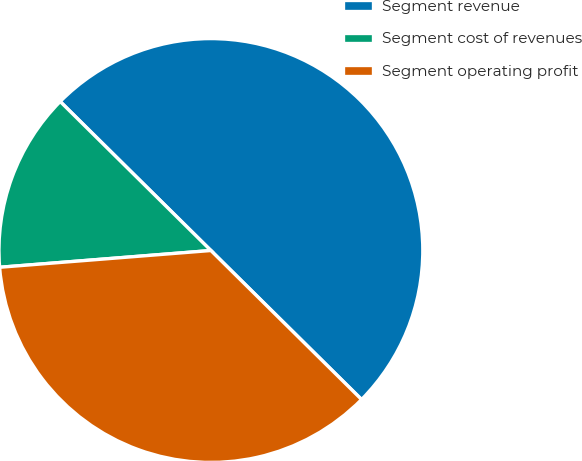<chart> <loc_0><loc_0><loc_500><loc_500><pie_chart><fcel>Segment revenue<fcel>Segment cost of revenues<fcel>Segment operating profit<nl><fcel>50.0%<fcel>13.67%<fcel>36.33%<nl></chart> 